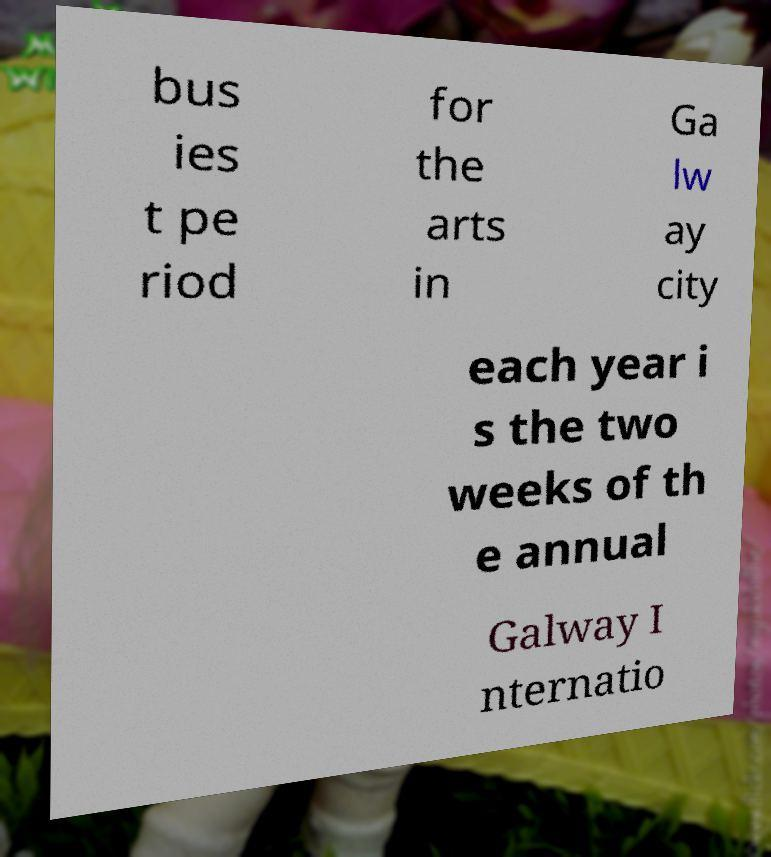Please identify and transcribe the text found in this image. bus ies t pe riod for the arts in Ga lw ay city each year i s the two weeks of th e annual Galway I nternatio 